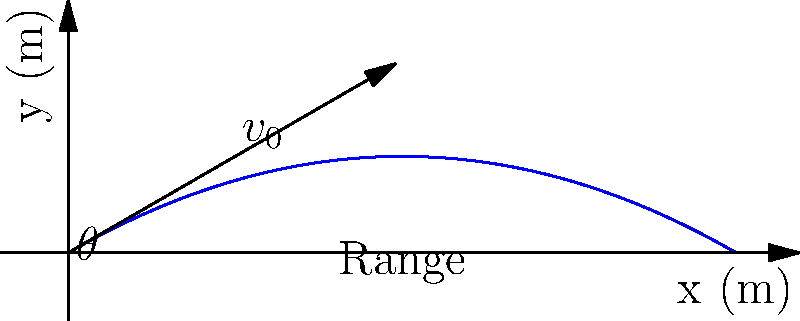A soft tennis ball is hit with an initial velocity of 20 m/s at an angle of 30° above the horizontal. Neglecting air resistance, what is the maximum height reached by the ball? Round your answer to the nearest tenth of a meter. To find the maximum height, we can follow these steps:

1) The vertical component of the initial velocity is given by:
   $v_{0y} = v_0 \sin(\theta) = 20 \sin(30°) = 10$ m/s

2) The time to reach the maximum height is when the vertical velocity becomes zero:
   $t_{max} = \frac{v_{0y}}{g} = \frac{10}{9.8} \approx 1.02$ seconds

3) The maximum height can be calculated using the equation:
   $h_{max} = v_{0y}t - \frac{1}{2}gt^2$

4) Substituting the values:
   $h_{max} = 10 \cdot 1.02 - \frac{1}{2} \cdot 9.8 \cdot 1.02^2$
   $h_{max} = 10.2 - 5.1$
   $h_{max} = 5.1$ meters

5) Rounding to the nearest tenth:
   $h_{max} \approx 5.1$ meters
Answer: 5.1 m 